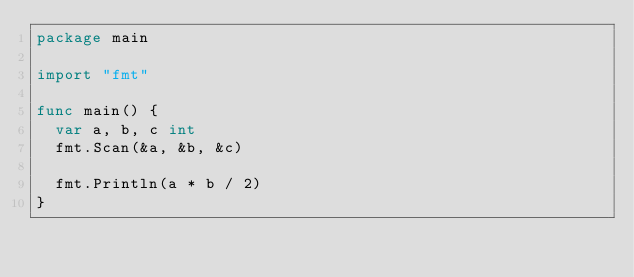<code> <loc_0><loc_0><loc_500><loc_500><_Go_>package main

import "fmt"

func main() {
	var a, b, c int
	fmt.Scan(&a, &b, &c)

	fmt.Println(a * b / 2)
}
</code> 